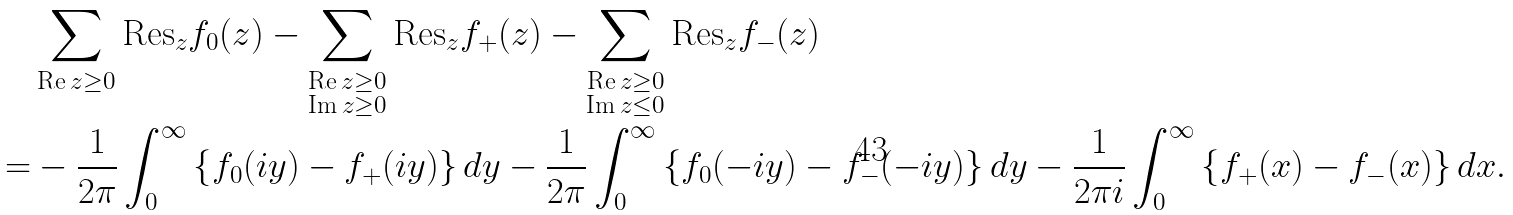<formula> <loc_0><loc_0><loc_500><loc_500>& \sum _ { \text {Re} \, z \geq 0 } \text {Res} _ { z } f _ { 0 } ( z ) - \sum _ { \substack { \text {Re} \, z \geq 0 \\ \text {Im} \, z \geq 0 } } \text {Res} _ { z } f _ { + } ( z ) - \sum _ { \substack { \text {Re} \, z \geq 0 \\ \text {Im} \, z \leq 0 } } \text {Res} _ { z } f _ { - } ( z ) \\ = & - \frac { 1 } { 2 \pi } \int _ { 0 } ^ { \infty } \left \{ f _ { 0 } ( i y ) - f _ { + } ( i y ) \right \} d y - \frac { 1 } { 2 \pi } \int _ { 0 } ^ { \infty } \left \{ f _ { 0 } ( - i y ) - f _ { - } ( - i y ) \right \} d y - \frac { 1 } { 2 \pi i } \int _ { 0 } ^ { \infty } \left \{ f _ { + } ( x ) - f _ { - } ( x ) \right \} d x .</formula> 